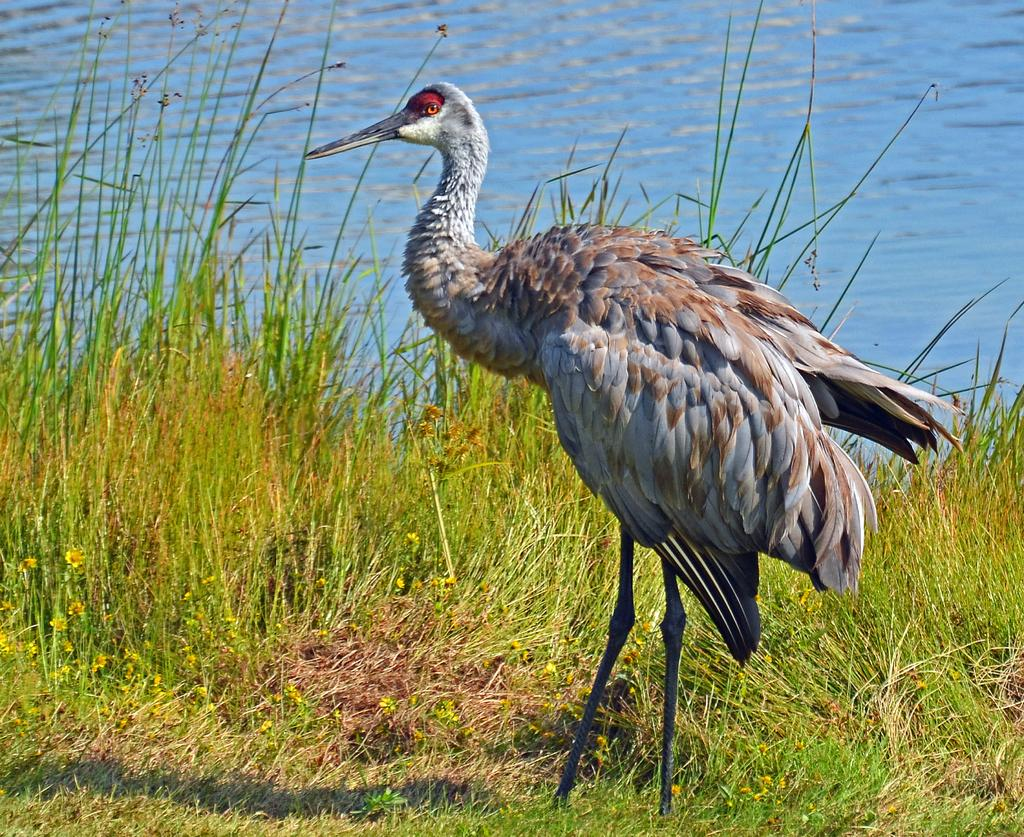What type of machinery is present in the image? There is a crane in the image. What type of vegetation can be seen in the image? There is grass and flowers in the image. What can be seen in the background of the image? There is water visible in the background of the image. What book is the turkey reading in the image? There is no turkey or book present in the image. What type of plants are growing in the image? The image features grass and flowers, which are both types of plants. 